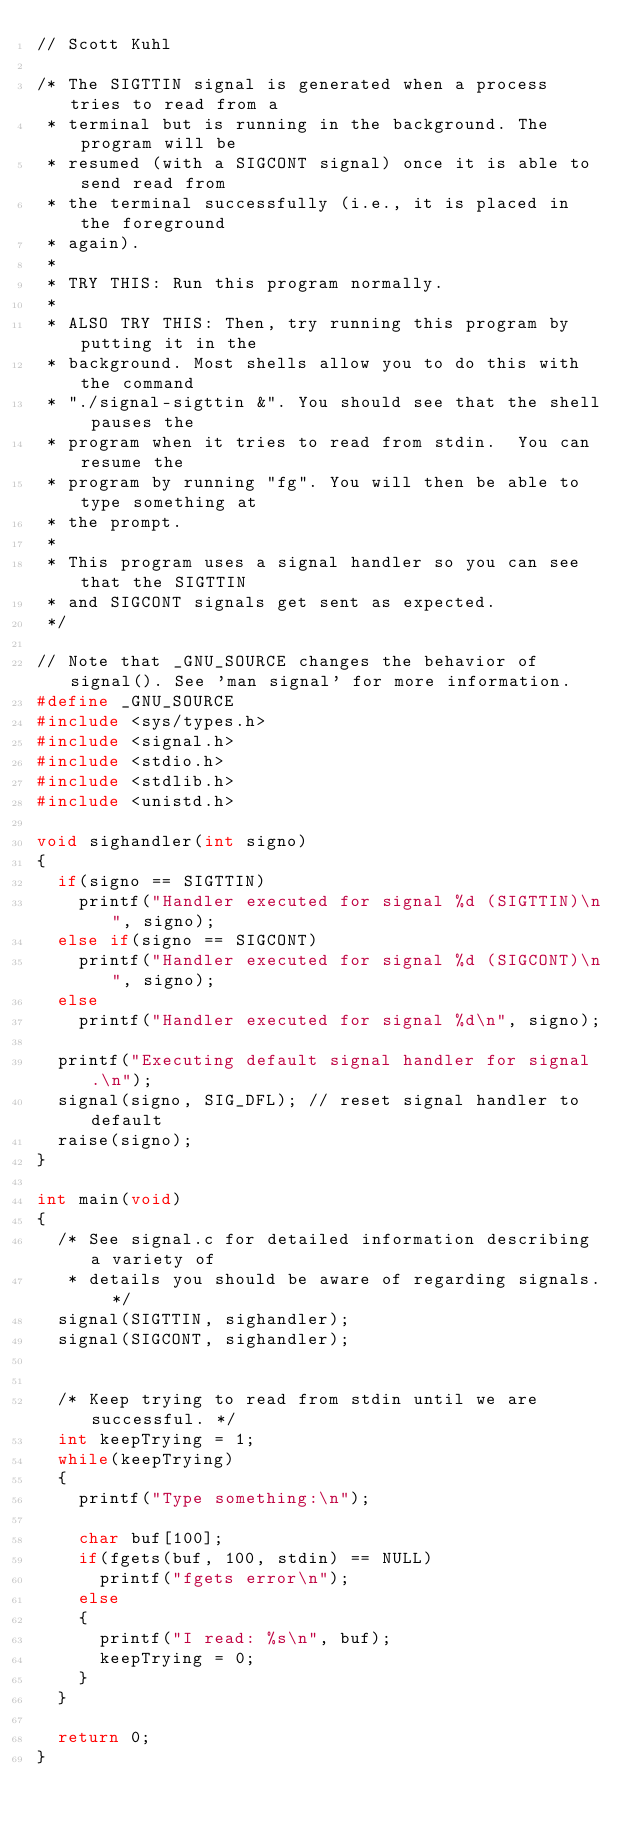<code> <loc_0><loc_0><loc_500><loc_500><_C_>// Scott Kuhl

/* The SIGTTIN signal is generated when a process tries to read from a
 * terminal but is running in the background. The program will be
 * resumed (with a SIGCONT signal) once it is able to send read from
 * the terminal successfully (i.e., it is placed in the foreground
 * again).
 *
 * TRY THIS: Run this program normally.
 *
 * ALSO TRY THIS: Then, try running this program by putting it in the
 * background. Most shells allow you to do this with the command
 * "./signal-sigttin &". You should see that the shell pauses the
 * program when it tries to read from stdin.  You can resume the
 * program by running "fg". You will then be able to type something at
 * the prompt.
 *
 * This program uses a signal handler so you can see that the SIGTTIN
 * and SIGCONT signals get sent as expected.
 */

// Note that _GNU_SOURCE changes the behavior of signal(). See 'man signal' for more information.
#define _GNU_SOURCE
#include <sys/types.h>
#include <signal.h>
#include <stdio.h>
#include <stdlib.h>
#include <unistd.h>

void sighandler(int signo)
{
	if(signo == SIGTTIN)
		printf("Handler executed for signal %d (SIGTTIN)\n", signo);
	else if(signo == SIGCONT)
		printf("Handler executed for signal %d (SIGCONT)\n", signo);
	else
		printf("Handler executed for signal %d\n", signo);
		
	printf("Executing default signal handler for signal.\n");
	signal(signo, SIG_DFL); // reset signal handler to default
	raise(signo);
}

int main(void)
{
	/* See signal.c for detailed information describing a variety of
	 * details you should be aware of regarding signals. */
	signal(SIGTTIN, sighandler);
	signal(SIGCONT, sighandler);


	/* Keep trying to read from stdin until we are successful. */
	int keepTrying = 1;
	while(keepTrying)
	{
		printf("Type something:\n");
		
		char buf[100];
		if(fgets(buf, 100, stdin) == NULL)
			printf("fgets error\n");
		else
		{
			printf("I read: %s\n", buf);
			keepTrying = 0;
		}
	}

	return 0;
}
</code> 